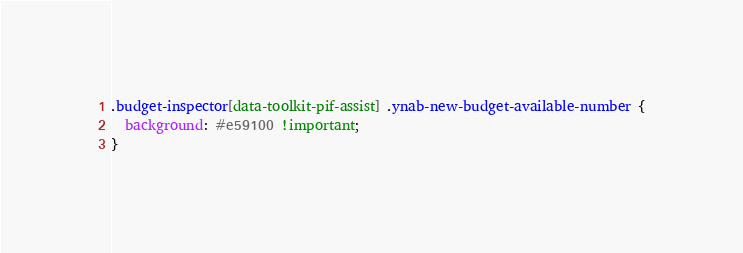<code> <loc_0><loc_0><loc_500><loc_500><_CSS_>.budget-inspector[data-toolkit-pif-assist] .ynab-new-budget-available-number {
  background: #e59100 !important;
}
</code> 